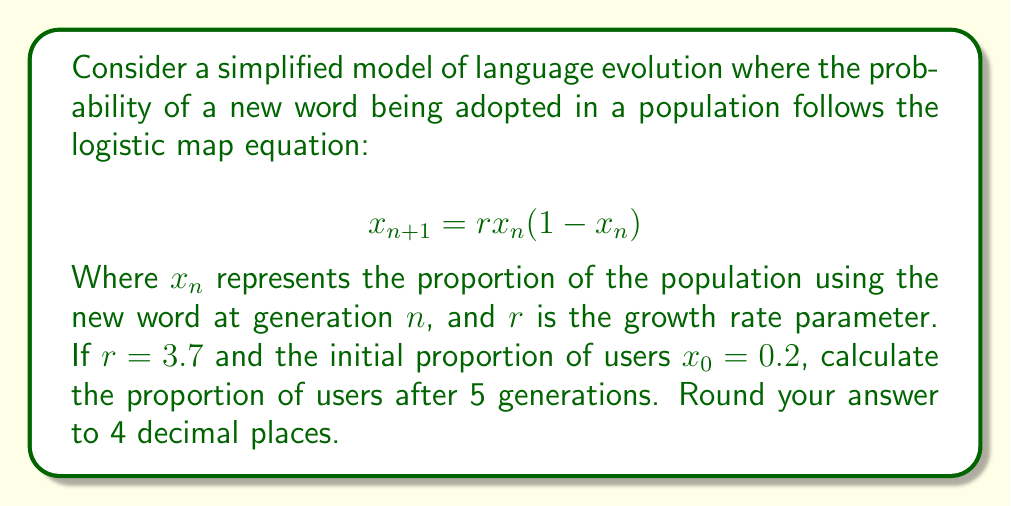Can you solve this math problem? To solve this problem, we need to iterate the logistic map equation for 5 generations:

1. Start with $x_0 = 0.2$ and $r = 3.7$

2. For $n = 0$ (first generation):
   $x_1 = 3.7 \cdot 0.2 \cdot (1-0.2) = 0.592$

3. For $n = 1$ (second generation):
   $x_2 = 3.7 \cdot 0.592 \cdot (1-0.592) = 0.8910$

4. For $n = 2$ (third generation):
   $x_3 = 3.7 \cdot 0.8910 \cdot (1-0.8910) = 0.3589$

5. For $n = 3$ (fourth generation):
   $x_4 = 3.7 \cdot 0.3589 \cdot (1-0.3589) = 0.8501$

6. For $n = 4$ (fifth generation):
   $x_5 = 3.7 \cdot 0.8501 \cdot (1-0.8501) = 0.4712$

7. Round the final result to 4 decimal places: 0.4712

This demonstrates the butterfly effect in language evolution, as small changes in initial conditions can lead to significant and unpredictable changes over time.
Answer: 0.4712 